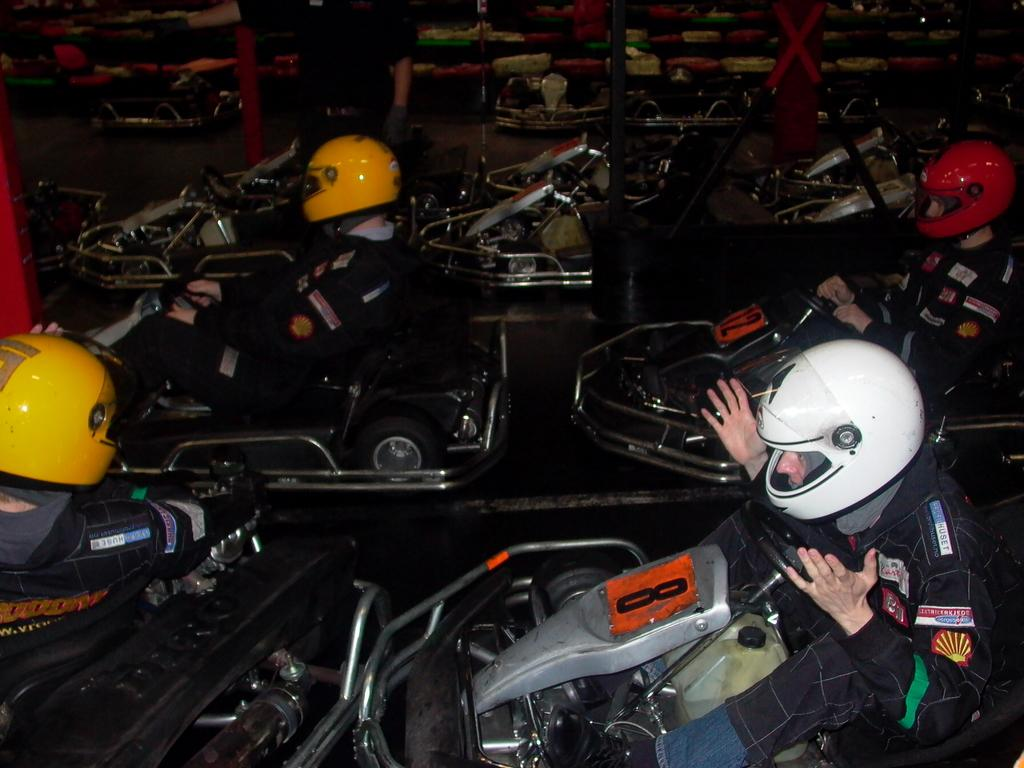Who is present in the image? There are people in the image. What are the people wearing? The people are wearing helmets. What are the people doing in the image? The people are sitting in go karting cars. What advice is the person in the sky giving to the people in the image? There is no person in the sky present in the image, and therefore no advice can be given. 